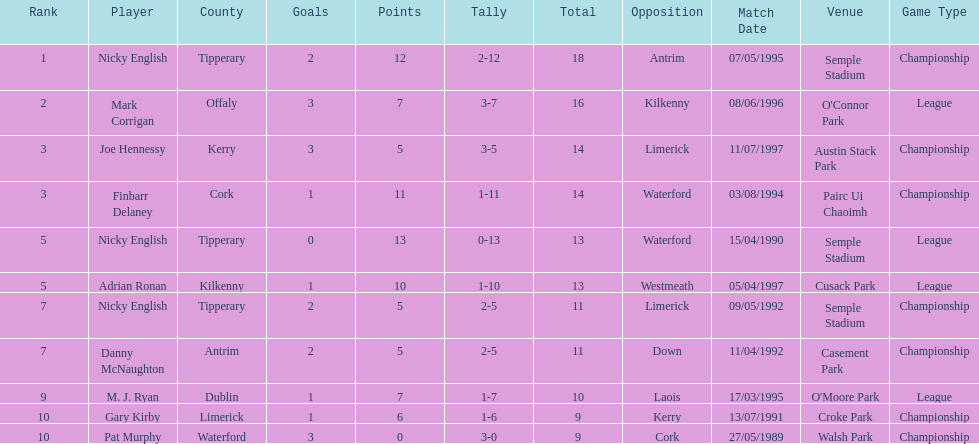What was the combined total of nicky english and mark corrigan? 34. 